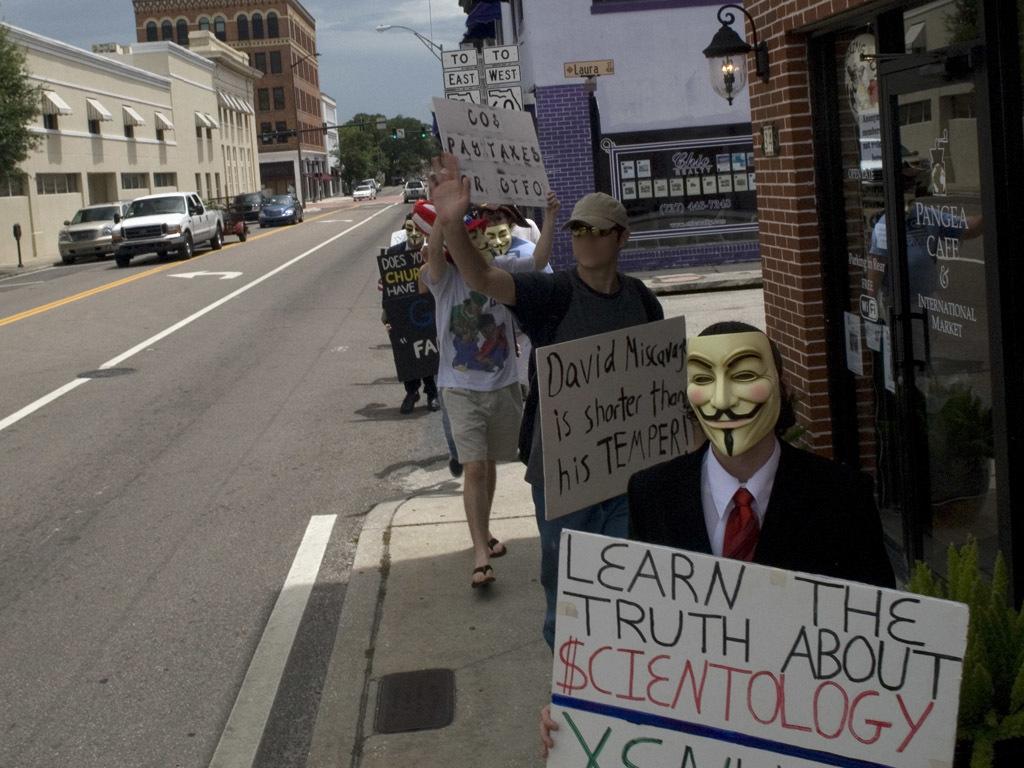Could you give a brief overview of what you see in this image? In this image, on the right there is a person, wearing a suit, shirt, tie, holding a board, behind the person there are people, some are holding boards, they are walking. At the bottom there is a road. In the background there are buildings, lights, trees, vehicles, posters, sky and clouds. 